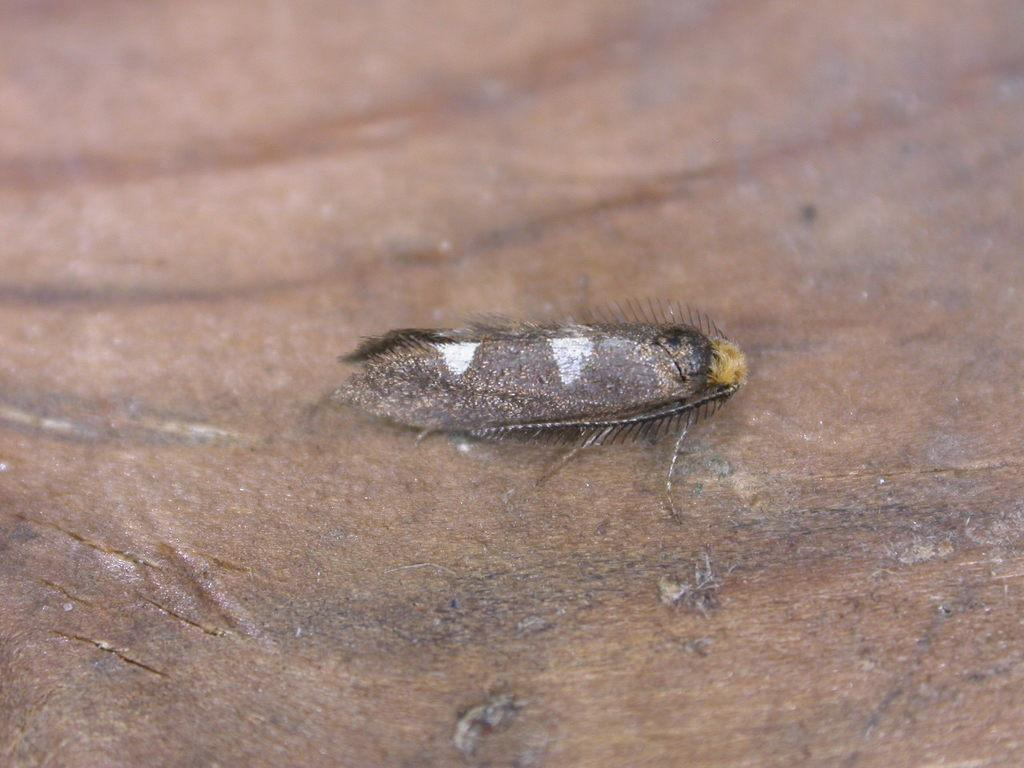What is present in the image? There is an insect in the image. What is the insect resting on? The insect is on a wooden board. How many apples are on the wooden board in the image? There are no apples present in the image; it only features an insect on a wooden board. 